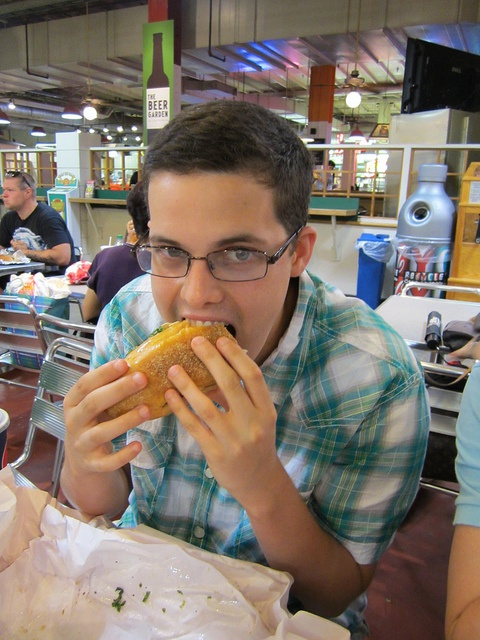Describe the objects in this image and their specific colors. I can see people in black, gray, and darkgray tones, dining table in black, tan, and lightgray tones, chair in black, maroon, and brown tones, people in black, darkgray, gray, and brown tones, and bottle in black, darkgray, lightblue, and gray tones in this image. 